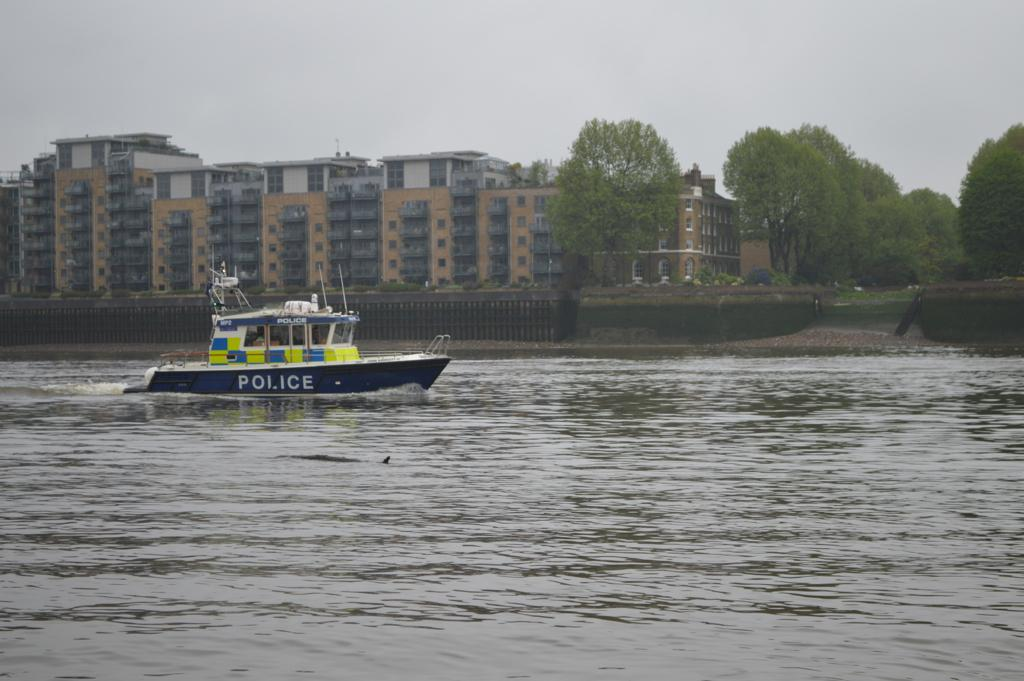What is the main subject in the foreground of the image? There is a boat in the foreground of the image. What is the boat's location in relation to the water? The boat is in the water. What can be seen in the background of the image? There are trees, a fence, buildings, and the sky visible in the background of the image. Can you describe the setting where the image might have been taken? The image may have been taken near a lake, given the presence of water and the boat. What type of flesh can be seen on the boat in the image? There is no flesh visible on the boat in the image. Who is the partner of the person standing on the boat in the image? There is no person standing on the boat in the image, so there is no partner to identify. 